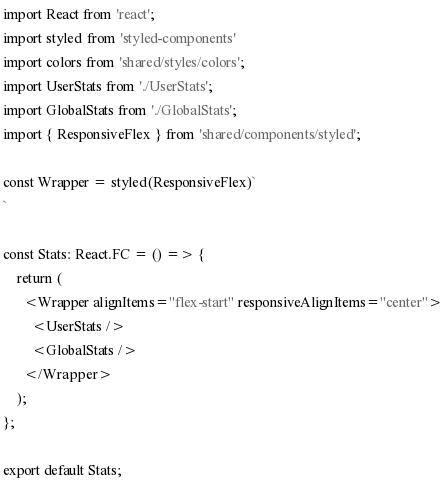<code> <loc_0><loc_0><loc_500><loc_500><_TypeScript_>import React from 'react';
import styled from 'styled-components'
import colors from 'shared/styles/colors';
import UserStats from './UserStats';
import GlobalStats from './GlobalStats';
import { ResponsiveFlex } from 'shared/components/styled';

const Wrapper = styled(ResponsiveFlex)`
`

const Stats: React.FC = () => {
    return (
      <Wrapper alignItems="flex-start" responsiveAlignItems="center">
        <UserStats />
        <GlobalStats />
      </Wrapper>
    );
};

export default Stats;
</code> 